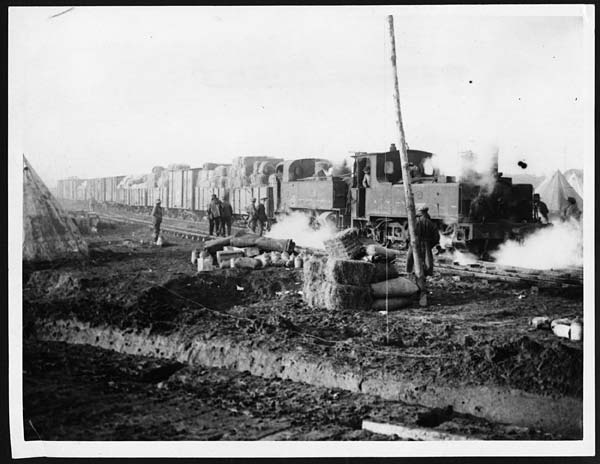Describe the objects in this image and their specific colors. I can see train in black, darkgray, lightgray, and gray tones, people in black, gray, and lightgray tones, people in black, gray, darkgray, and lightgray tones, people in black, gray, darkgray, and lightgray tones, and people in gray and black tones in this image. 